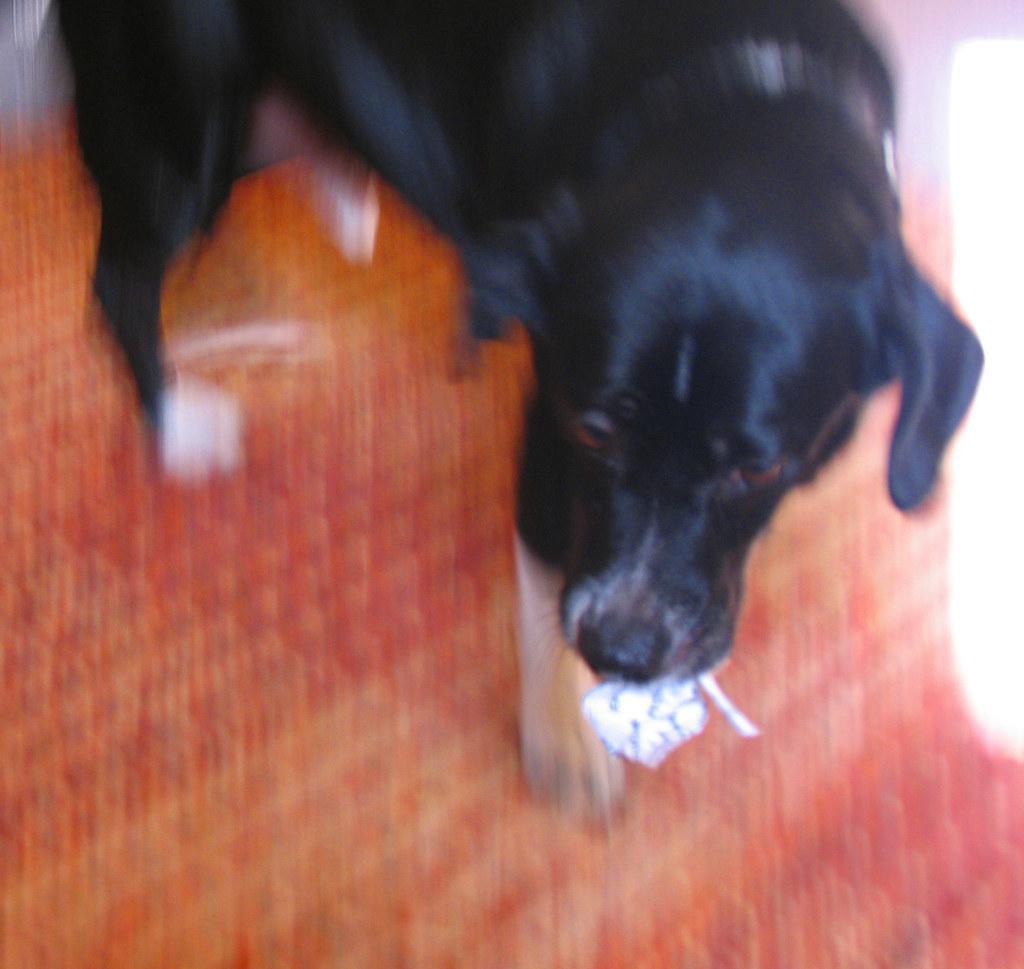Please provide a concise description of this image. This is a zoomed in picture. In the center there is a black color dog holding some item in his mouth and standing on the ground. 